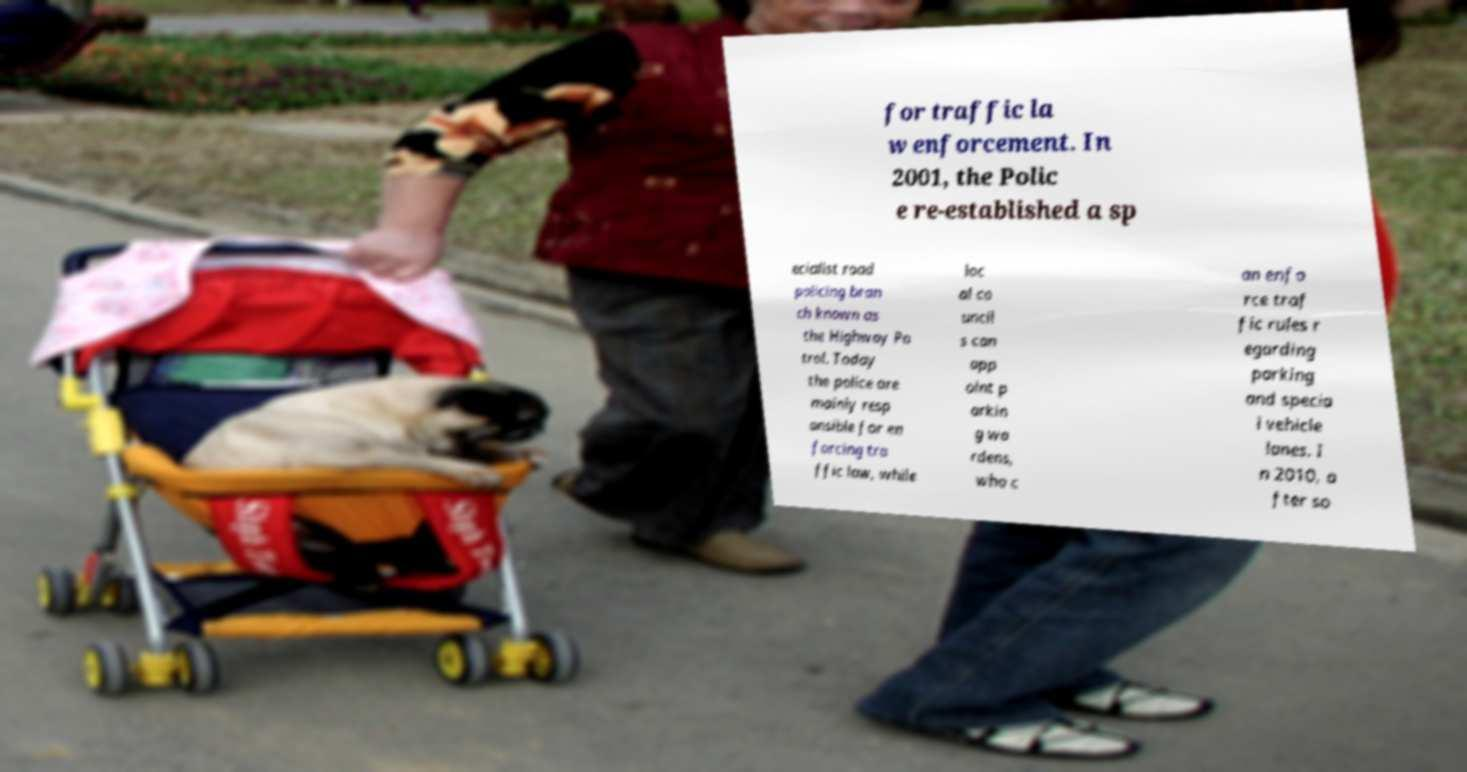Please read and relay the text visible in this image. What does it say? for traffic la w enforcement. In 2001, the Polic e re-established a sp ecialist road policing bran ch known as the Highway Pa trol. Today the police are mainly resp onsible for en forcing tra ffic law, while loc al co uncil s can app oint p arkin g wa rdens, who c an enfo rce traf fic rules r egarding parking and specia l vehicle lanes. I n 2010, a fter so 